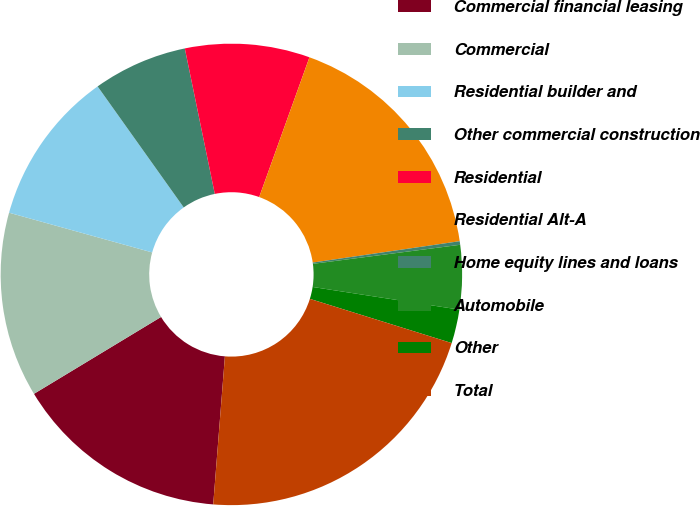<chart> <loc_0><loc_0><loc_500><loc_500><pie_chart><fcel>Commercial financial leasing<fcel>Commercial<fcel>Residential builder and<fcel>Other commercial construction<fcel>Residential<fcel>Residential Alt-A<fcel>Home equity lines and loans<fcel>Automobile<fcel>Other<fcel>Total<nl><fcel>15.09%<fcel>12.97%<fcel>10.85%<fcel>6.61%<fcel>8.73%<fcel>17.21%<fcel>0.25%<fcel>4.49%<fcel>2.37%<fcel>21.45%<nl></chart> 